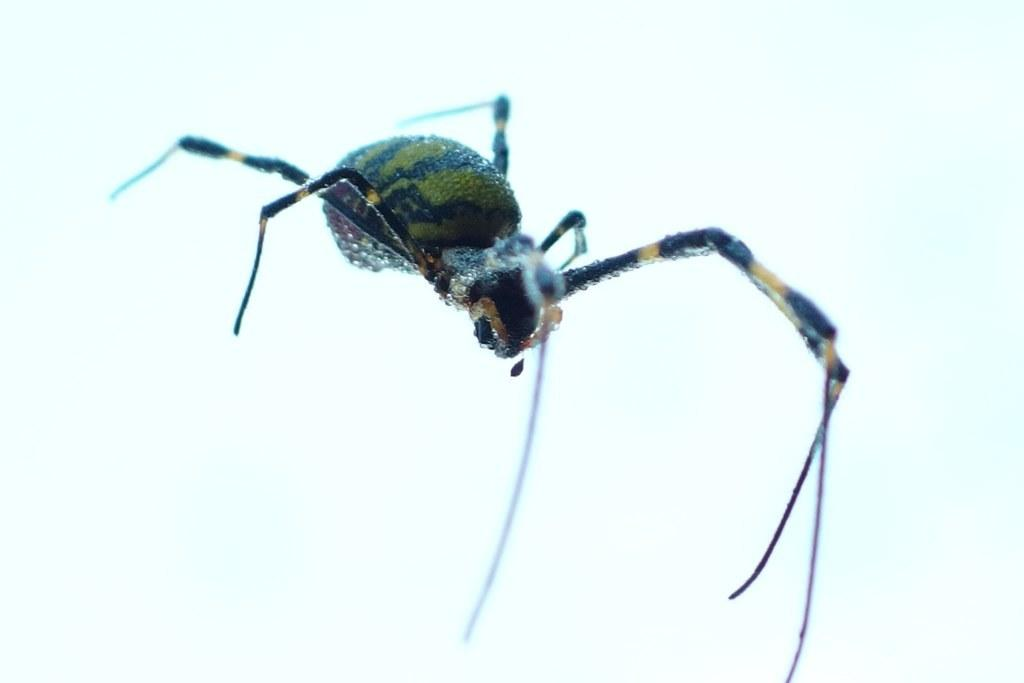What is the main subject of the image? There is a spider in the image. Can you describe the colors of the spider? The spider has green, black, and yellow colors. What color is the background of the image? The background of the image is white. What is the rate of the hole in the image? There is no hole present in the image, so it's not possible to determine a rate. 